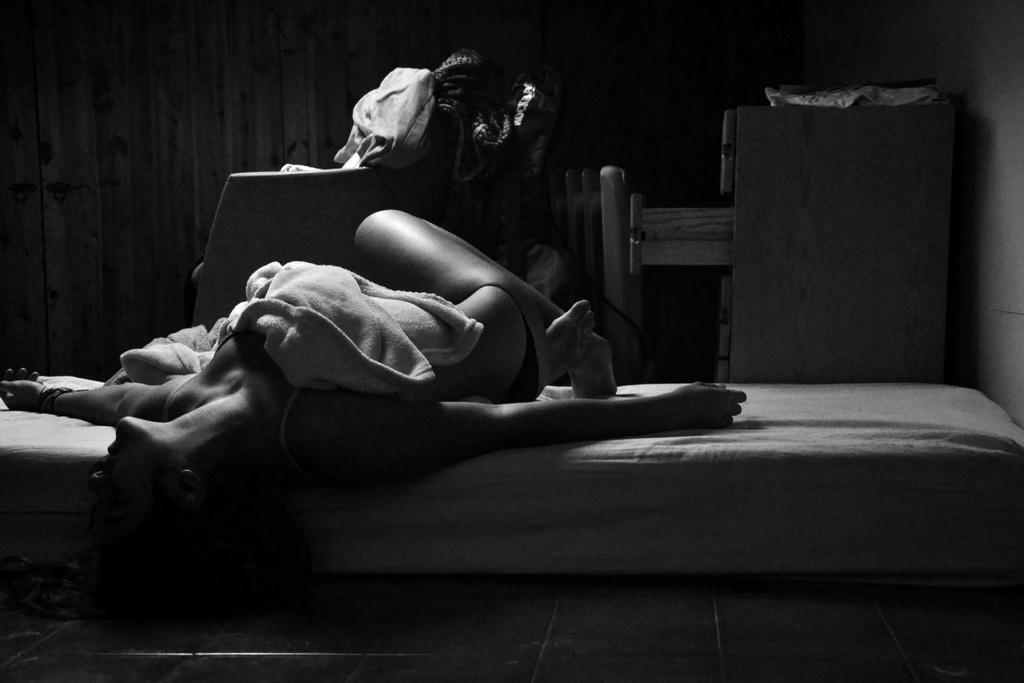What is the woman doing in the image? The woman is on a bed in the image. What is covering the woman's body? The woman has a cloth on her body. What can be seen in the background of the image? There are clothes on an object in the background, and there is a cupboard in the background. How would you describe the color of the background? The background is dark in color. What type of wave can be seen crashing on the shore in the image? There is no wave or shore present in the image; it features a woman on a bed with a dark background. 